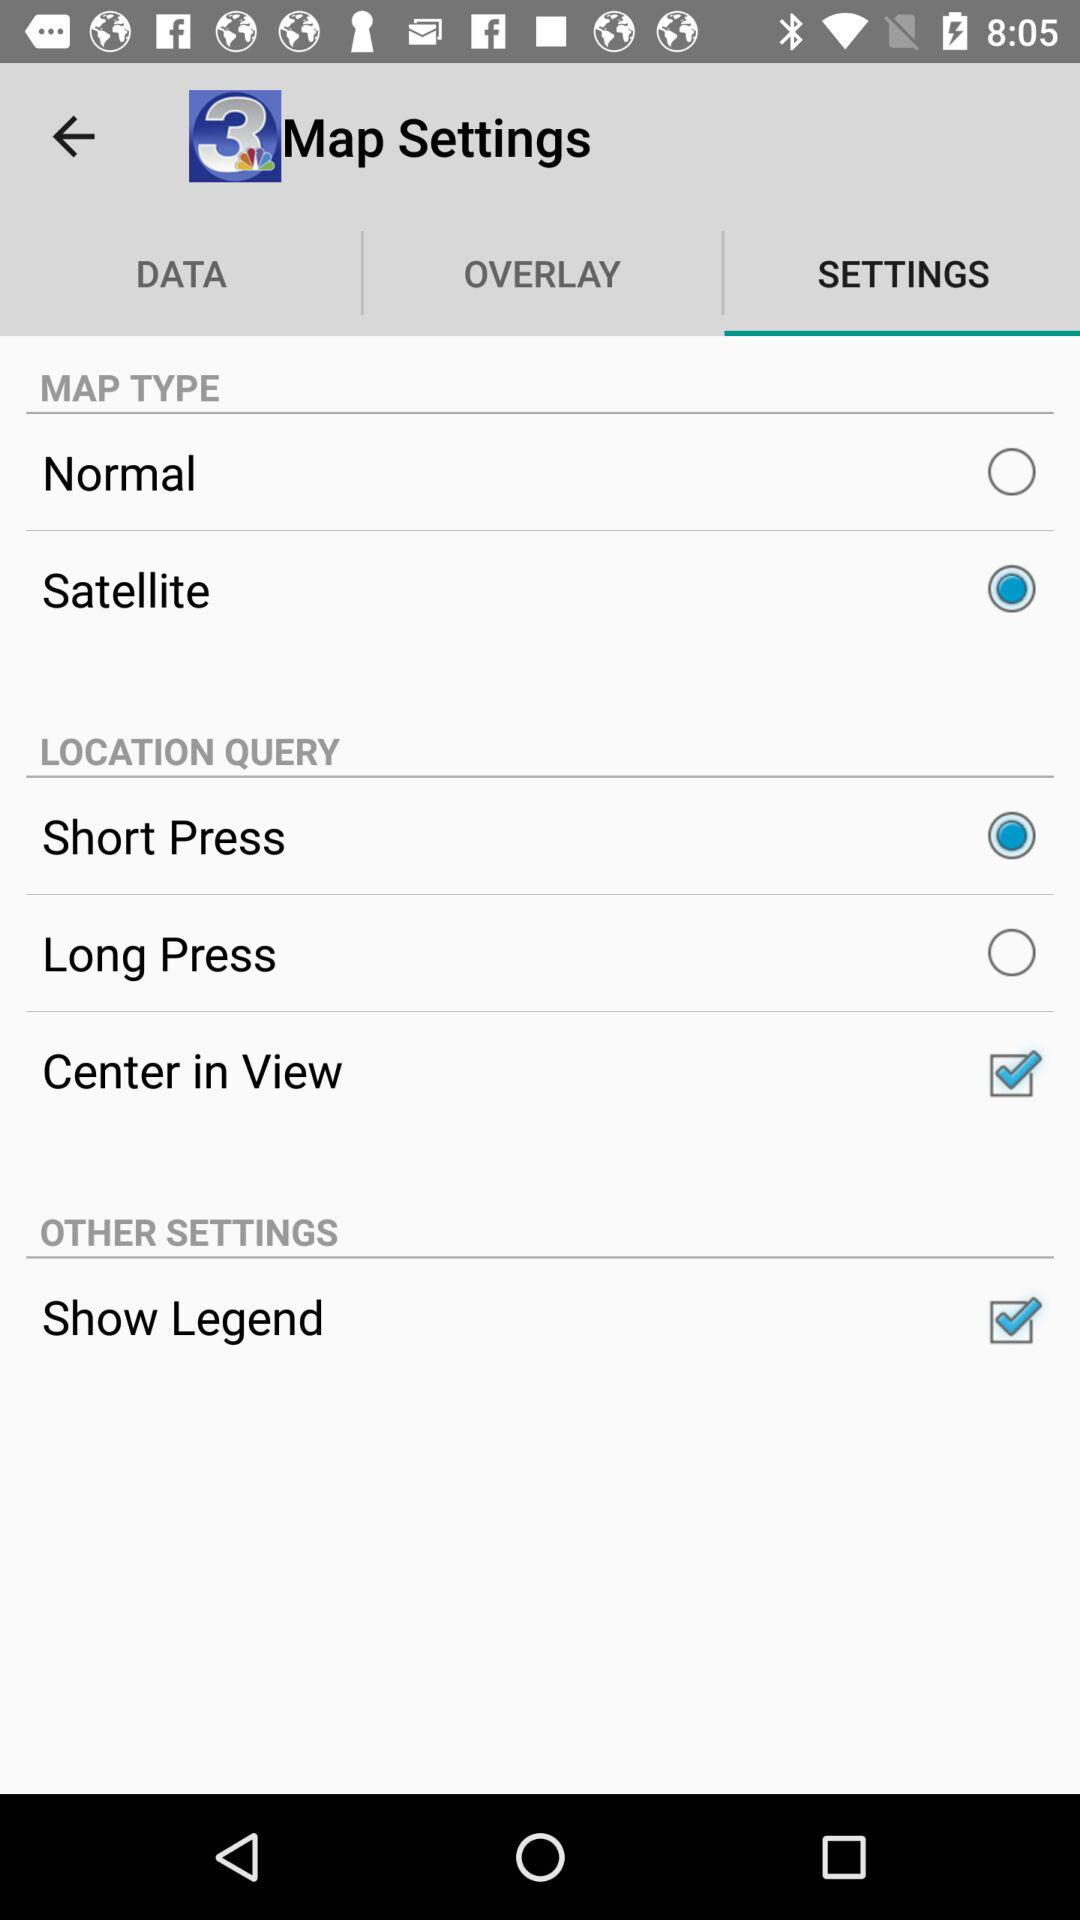What are the setting options in "LOCATION QUERY"? The setting options in "LOCATION QUERY" are "Short Press", "Long Press" and "Center in View". 